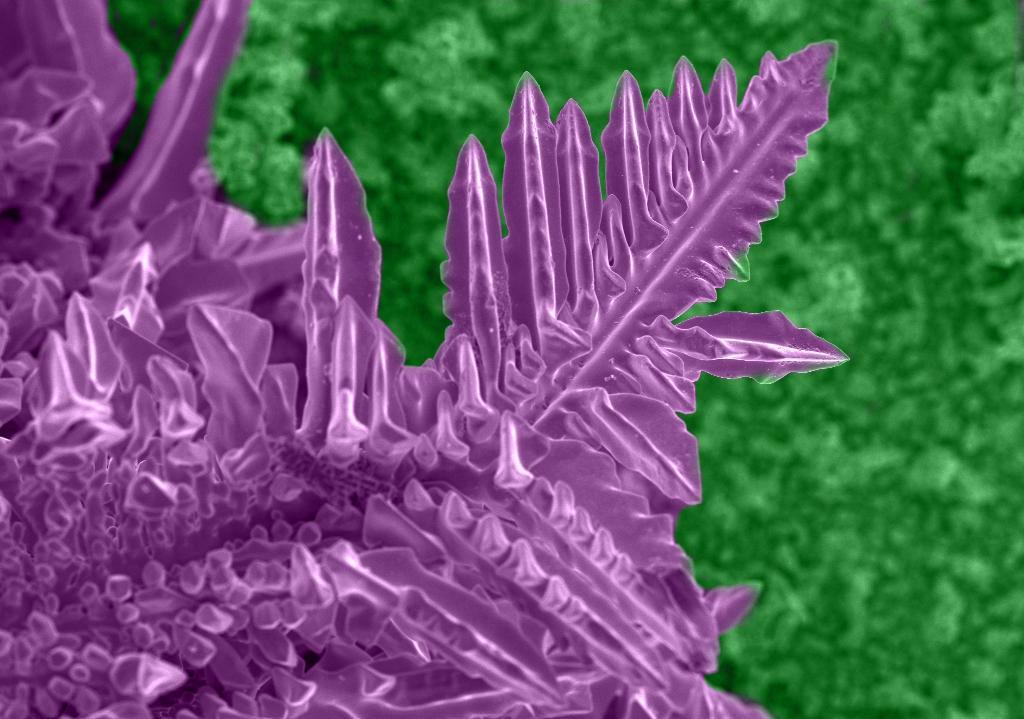In one or two sentences, can you explain what this image depicts? In this image we can see some plants, some are in green color, and some are in purple color. 